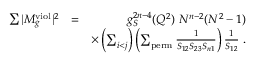Convert formula to latex. <formula><loc_0><loc_0><loc_500><loc_500>\begin{array} { r l r } { \sum | M _ { g } ^ { v i o l } | ^ { 2 } } & { = } & { g _ { S } ^ { 2 n - 4 } ( Q ^ { 2 } ) N ^ { n - 2 } ( N ^ { 2 } - 1 ) } \\ & { \times \left ( \sum _ { i < j } \right ) \left ( \sum _ { p e r m } \frac { 1 } { S _ { 1 2 } S _ { 2 3 } S _ { n 1 } } \right ) \frac { 1 } { S _ { 1 2 } } . } \end{array}</formula> 